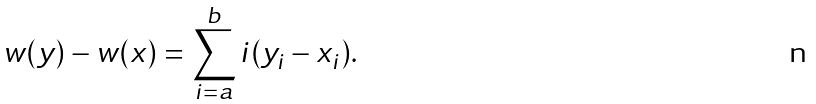<formula> <loc_0><loc_0><loc_500><loc_500>w ( y ) - w ( x ) = \sum _ { i = a } ^ { b } i ( y _ { i } - x _ { i } ) .</formula> 